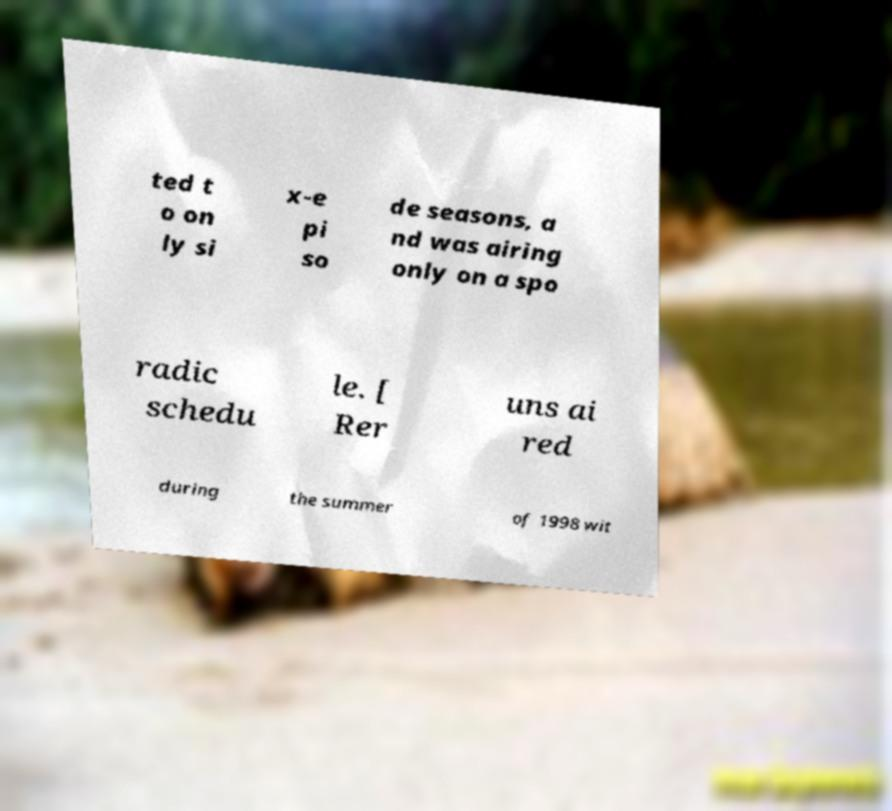Please identify and transcribe the text found in this image. ted t o on ly si x-e pi so de seasons, a nd was airing only on a spo radic schedu le. [ Rer uns ai red during the summer of 1998 wit 